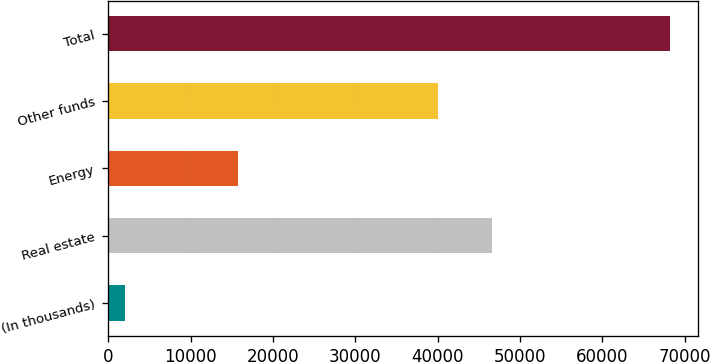<chart> <loc_0><loc_0><loc_500><loc_500><bar_chart><fcel>(In thousands)<fcel>Real estate<fcel>Energy<fcel>Other funds<fcel>Total<nl><fcel>2017<fcel>46644.2<fcel>15764<fcel>40029<fcel>68169<nl></chart> 